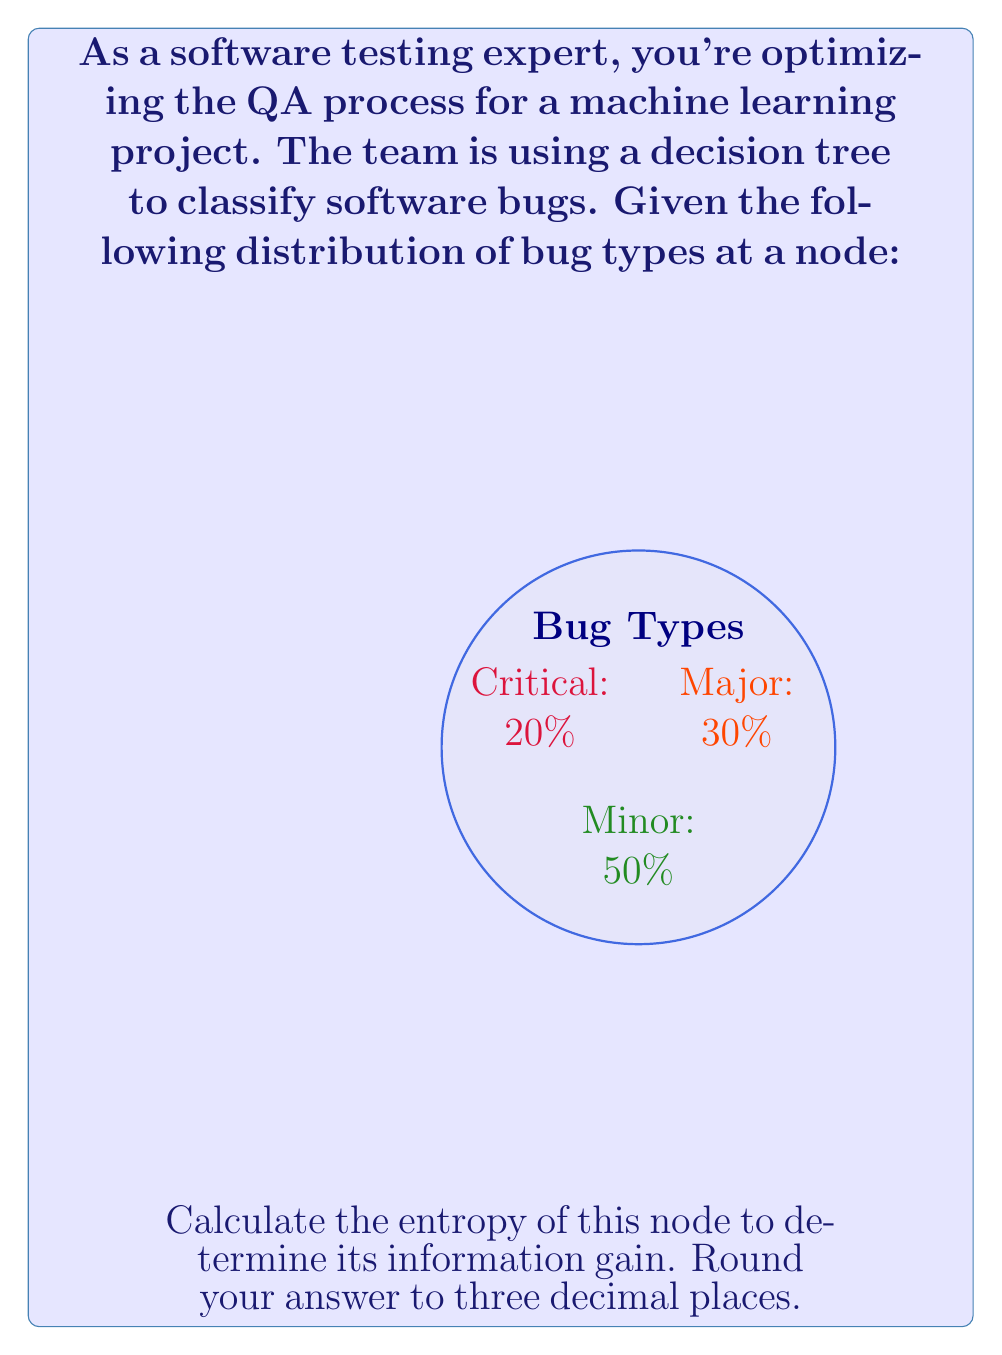Teach me how to tackle this problem. To calculate the entropy of the node, we'll use the formula:

$$H = -\sum_{i=1}^{n} p_i \log_2(p_i)$$

Where $p_i$ is the probability of each class.

Given:
- Critical bugs: 20% = 0.2
- Major bugs: 30% = 0.3
- Minor bugs: 50% = 0.5

Step 1: Calculate each term in the sum:
- For Critical: $-0.2 \log_2(0.2)$
- For Major: $-0.3 \log_2(0.3)$
- For Minor: $-0.5 \log_2(0.5)$

Step 2: Calculate the logarithms:
- $\log_2(0.2) \approx -2.3219$
- $\log_2(0.3) \approx -1.7370$
- $\log_2(0.5) = -1$

Step 3: Multiply each probability by its log and sum:
$$H = -[0.2 * (-2.3219) + 0.3 * (-1.7370) + 0.5 * (-1)]$$

Step 4: Simplify:
$$H = 0.4644 + 0.5211 + 0.5 = 1.4855$$

Step 5: Round to three decimal places:
$$H \approx 1.486$$
Answer: 1.486 